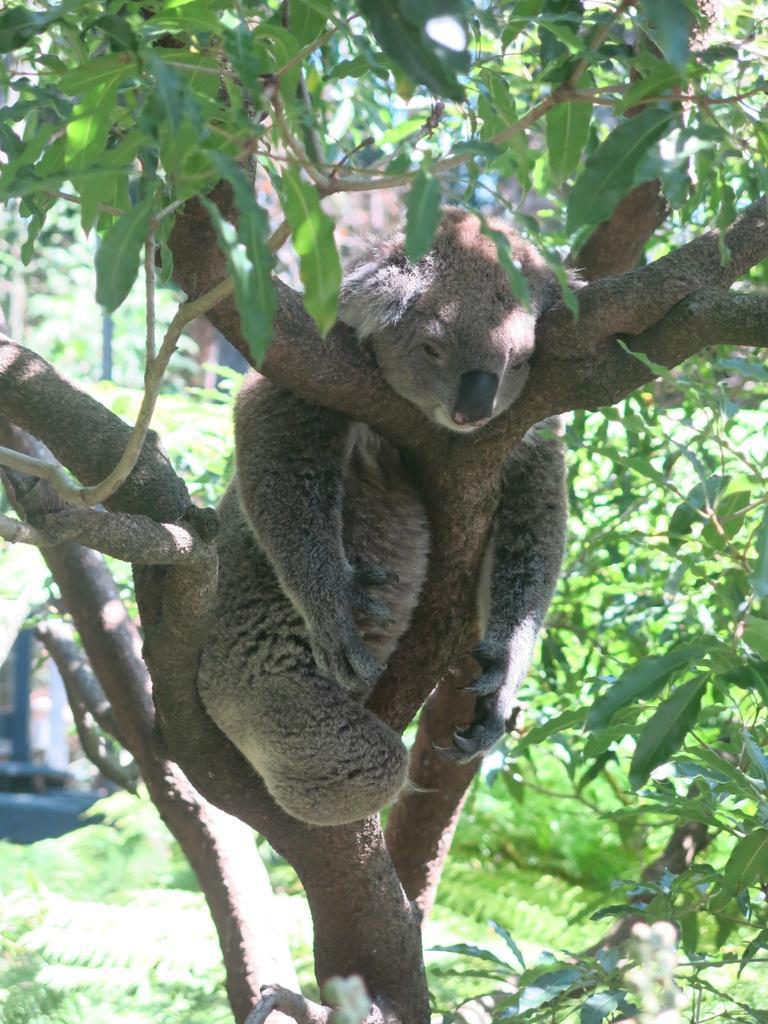Can you describe this image briefly? In the foreground of the picture I can see an animal on the branch of a tree. 